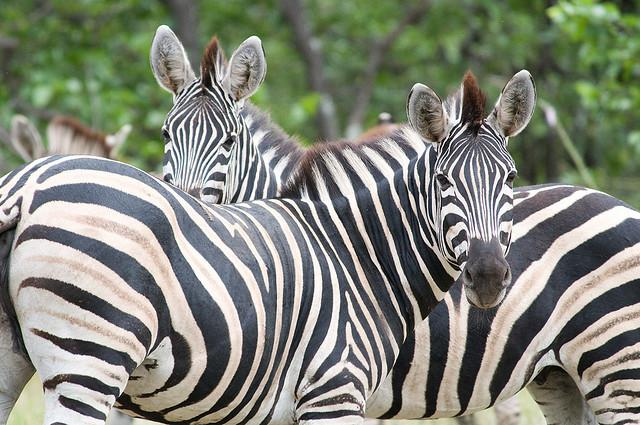How many zebras are standing in the forest with their noses pointed at the cameras? two 